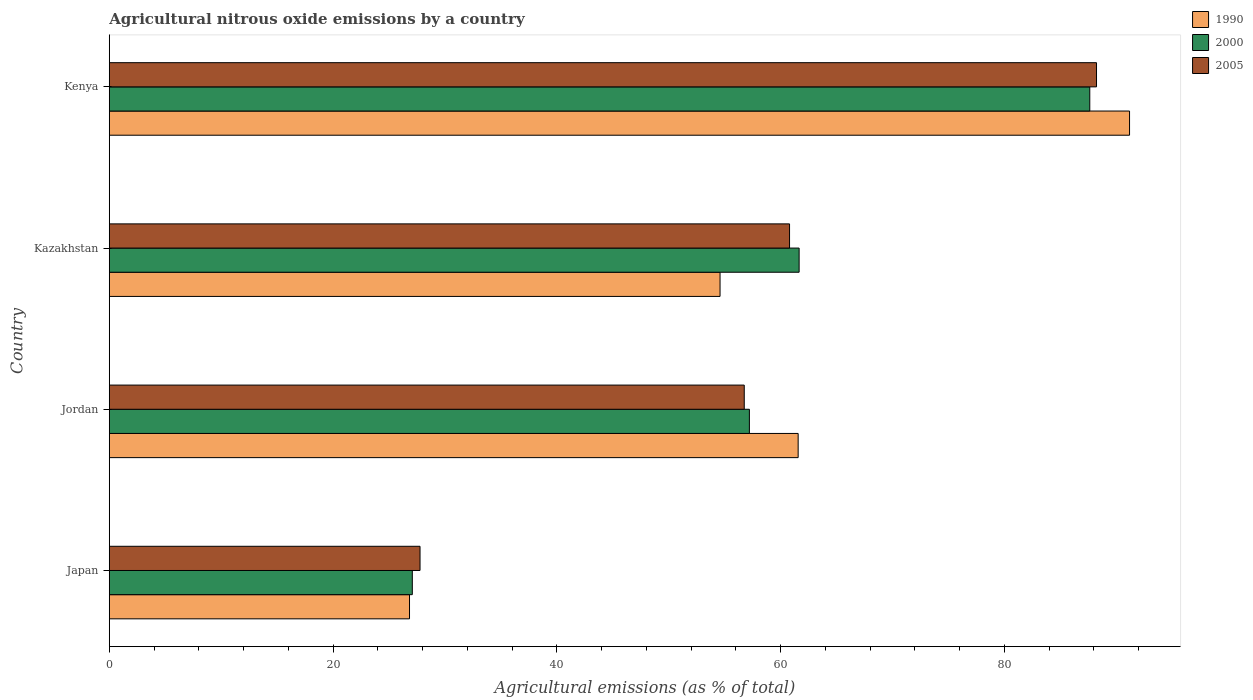How many groups of bars are there?
Ensure brevity in your answer.  4. How many bars are there on the 3rd tick from the top?
Offer a very short reply. 3. What is the label of the 2nd group of bars from the top?
Provide a succinct answer. Kazakhstan. In how many cases, is the number of bars for a given country not equal to the number of legend labels?
Provide a succinct answer. 0. What is the amount of agricultural nitrous oxide emitted in 2000 in Kenya?
Your answer should be very brief. 87.65. Across all countries, what is the maximum amount of agricultural nitrous oxide emitted in 2000?
Ensure brevity in your answer.  87.65. Across all countries, what is the minimum amount of agricultural nitrous oxide emitted in 2000?
Your answer should be compact. 27.09. In which country was the amount of agricultural nitrous oxide emitted in 2000 maximum?
Offer a terse response. Kenya. In which country was the amount of agricultural nitrous oxide emitted in 1990 minimum?
Ensure brevity in your answer.  Japan. What is the total amount of agricultural nitrous oxide emitted in 2005 in the graph?
Give a very brief answer. 233.59. What is the difference between the amount of agricultural nitrous oxide emitted in 2000 in Kazakhstan and that in Kenya?
Your response must be concise. -25.98. What is the difference between the amount of agricultural nitrous oxide emitted in 1990 in Japan and the amount of agricultural nitrous oxide emitted in 2005 in Kenya?
Ensure brevity in your answer.  -61.41. What is the average amount of agricultural nitrous oxide emitted in 2000 per country?
Make the answer very short. 58.4. What is the difference between the amount of agricultural nitrous oxide emitted in 2000 and amount of agricultural nitrous oxide emitted in 2005 in Kazakhstan?
Keep it short and to the point. 0.86. In how many countries, is the amount of agricultural nitrous oxide emitted in 2000 greater than 12 %?
Ensure brevity in your answer.  4. What is the ratio of the amount of agricultural nitrous oxide emitted in 1990 in Japan to that in Kazakhstan?
Make the answer very short. 0.49. Is the amount of agricultural nitrous oxide emitted in 1990 in Jordan less than that in Kenya?
Your answer should be compact. Yes. What is the difference between the highest and the second highest amount of agricultural nitrous oxide emitted in 1990?
Provide a succinct answer. 29.62. What is the difference between the highest and the lowest amount of agricultural nitrous oxide emitted in 1990?
Ensure brevity in your answer.  64.36. In how many countries, is the amount of agricultural nitrous oxide emitted in 2005 greater than the average amount of agricultural nitrous oxide emitted in 2005 taken over all countries?
Your response must be concise. 2. Is the sum of the amount of agricultural nitrous oxide emitted in 1990 in Japan and Kazakhstan greater than the maximum amount of agricultural nitrous oxide emitted in 2005 across all countries?
Your answer should be very brief. No. What does the 3rd bar from the top in Kazakhstan represents?
Your response must be concise. 1990. How many bars are there?
Offer a very short reply. 12. Are the values on the major ticks of X-axis written in scientific E-notation?
Offer a terse response. No. Does the graph contain any zero values?
Offer a very short reply. No. Does the graph contain grids?
Give a very brief answer. No. How many legend labels are there?
Ensure brevity in your answer.  3. What is the title of the graph?
Make the answer very short. Agricultural nitrous oxide emissions by a country. What is the label or title of the X-axis?
Ensure brevity in your answer.  Agricultural emissions (as % of total). What is the Agricultural emissions (as % of total) in 1990 in Japan?
Provide a short and direct response. 26.84. What is the Agricultural emissions (as % of total) in 2000 in Japan?
Your answer should be compact. 27.09. What is the Agricultural emissions (as % of total) of 2005 in Japan?
Provide a short and direct response. 27.78. What is the Agricultural emissions (as % of total) in 1990 in Jordan?
Offer a terse response. 61.58. What is the Agricultural emissions (as % of total) in 2000 in Jordan?
Provide a short and direct response. 57.22. What is the Agricultural emissions (as % of total) of 2005 in Jordan?
Your answer should be compact. 56.76. What is the Agricultural emissions (as % of total) in 1990 in Kazakhstan?
Provide a short and direct response. 54.6. What is the Agricultural emissions (as % of total) of 2000 in Kazakhstan?
Provide a short and direct response. 61.66. What is the Agricultural emissions (as % of total) in 2005 in Kazakhstan?
Give a very brief answer. 60.81. What is the Agricultural emissions (as % of total) of 1990 in Kenya?
Offer a very short reply. 91.2. What is the Agricultural emissions (as % of total) in 2000 in Kenya?
Your response must be concise. 87.65. What is the Agricultural emissions (as % of total) in 2005 in Kenya?
Make the answer very short. 88.25. Across all countries, what is the maximum Agricultural emissions (as % of total) in 1990?
Your answer should be compact. 91.2. Across all countries, what is the maximum Agricultural emissions (as % of total) of 2000?
Provide a short and direct response. 87.65. Across all countries, what is the maximum Agricultural emissions (as % of total) of 2005?
Keep it short and to the point. 88.25. Across all countries, what is the minimum Agricultural emissions (as % of total) in 1990?
Ensure brevity in your answer.  26.84. Across all countries, what is the minimum Agricultural emissions (as % of total) of 2000?
Provide a succinct answer. 27.09. Across all countries, what is the minimum Agricultural emissions (as % of total) of 2005?
Make the answer very short. 27.78. What is the total Agricultural emissions (as % of total) of 1990 in the graph?
Ensure brevity in your answer.  234.21. What is the total Agricultural emissions (as % of total) in 2000 in the graph?
Make the answer very short. 233.62. What is the total Agricultural emissions (as % of total) of 2005 in the graph?
Offer a very short reply. 233.59. What is the difference between the Agricultural emissions (as % of total) of 1990 in Japan and that in Jordan?
Your answer should be compact. -34.74. What is the difference between the Agricultural emissions (as % of total) of 2000 in Japan and that in Jordan?
Make the answer very short. -30.13. What is the difference between the Agricultural emissions (as % of total) in 2005 in Japan and that in Jordan?
Provide a short and direct response. -28.98. What is the difference between the Agricultural emissions (as % of total) in 1990 in Japan and that in Kazakhstan?
Provide a succinct answer. -27.76. What is the difference between the Agricultural emissions (as % of total) in 2000 in Japan and that in Kazakhstan?
Your answer should be compact. -34.58. What is the difference between the Agricultural emissions (as % of total) in 2005 in Japan and that in Kazakhstan?
Provide a succinct answer. -33.03. What is the difference between the Agricultural emissions (as % of total) of 1990 in Japan and that in Kenya?
Offer a terse response. -64.36. What is the difference between the Agricultural emissions (as % of total) of 2000 in Japan and that in Kenya?
Keep it short and to the point. -60.56. What is the difference between the Agricultural emissions (as % of total) in 2005 in Japan and that in Kenya?
Provide a short and direct response. -60.47. What is the difference between the Agricultural emissions (as % of total) in 1990 in Jordan and that in Kazakhstan?
Provide a succinct answer. 6.98. What is the difference between the Agricultural emissions (as % of total) of 2000 in Jordan and that in Kazakhstan?
Offer a very short reply. -4.45. What is the difference between the Agricultural emissions (as % of total) of 2005 in Jordan and that in Kazakhstan?
Give a very brief answer. -4.05. What is the difference between the Agricultural emissions (as % of total) of 1990 in Jordan and that in Kenya?
Your answer should be compact. -29.62. What is the difference between the Agricultural emissions (as % of total) in 2000 in Jordan and that in Kenya?
Make the answer very short. -30.43. What is the difference between the Agricultural emissions (as % of total) in 2005 in Jordan and that in Kenya?
Offer a very short reply. -31.49. What is the difference between the Agricultural emissions (as % of total) of 1990 in Kazakhstan and that in Kenya?
Give a very brief answer. -36.6. What is the difference between the Agricultural emissions (as % of total) of 2000 in Kazakhstan and that in Kenya?
Ensure brevity in your answer.  -25.98. What is the difference between the Agricultural emissions (as % of total) of 2005 in Kazakhstan and that in Kenya?
Make the answer very short. -27.44. What is the difference between the Agricultural emissions (as % of total) of 1990 in Japan and the Agricultural emissions (as % of total) of 2000 in Jordan?
Offer a very short reply. -30.38. What is the difference between the Agricultural emissions (as % of total) in 1990 in Japan and the Agricultural emissions (as % of total) in 2005 in Jordan?
Your answer should be very brief. -29.92. What is the difference between the Agricultural emissions (as % of total) in 2000 in Japan and the Agricultural emissions (as % of total) in 2005 in Jordan?
Offer a very short reply. -29.67. What is the difference between the Agricultural emissions (as % of total) of 1990 in Japan and the Agricultural emissions (as % of total) of 2000 in Kazakhstan?
Your response must be concise. -34.83. What is the difference between the Agricultural emissions (as % of total) of 1990 in Japan and the Agricultural emissions (as % of total) of 2005 in Kazakhstan?
Your response must be concise. -33.97. What is the difference between the Agricultural emissions (as % of total) in 2000 in Japan and the Agricultural emissions (as % of total) in 2005 in Kazakhstan?
Your answer should be very brief. -33.72. What is the difference between the Agricultural emissions (as % of total) of 1990 in Japan and the Agricultural emissions (as % of total) of 2000 in Kenya?
Give a very brief answer. -60.81. What is the difference between the Agricultural emissions (as % of total) of 1990 in Japan and the Agricultural emissions (as % of total) of 2005 in Kenya?
Provide a short and direct response. -61.41. What is the difference between the Agricultural emissions (as % of total) in 2000 in Japan and the Agricultural emissions (as % of total) in 2005 in Kenya?
Give a very brief answer. -61.16. What is the difference between the Agricultural emissions (as % of total) of 1990 in Jordan and the Agricultural emissions (as % of total) of 2000 in Kazakhstan?
Provide a succinct answer. -0.09. What is the difference between the Agricultural emissions (as % of total) in 1990 in Jordan and the Agricultural emissions (as % of total) in 2005 in Kazakhstan?
Keep it short and to the point. 0.77. What is the difference between the Agricultural emissions (as % of total) in 2000 in Jordan and the Agricultural emissions (as % of total) in 2005 in Kazakhstan?
Give a very brief answer. -3.59. What is the difference between the Agricultural emissions (as % of total) of 1990 in Jordan and the Agricultural emissions (as % of total) of 2000 in Kenya?
Make the answer very short. -26.07. What is the difference between the Agricultural emissions (as % of total) of 1990 in Jordan and the Agricultural emissions (as % of total) of 2005 in Kenya?
Give a very brief answer. -26.67. What is the difference between the Agricultural emissions (as % of total) of 2000 in Jordan and the Agricultural emissions (as % of total) of 2005 in Kenya?
Make the answer very short. -31.03. What is the difference between the Agricultural emissions (as % of total) of 1990 in Kazakhstan and the Agricultural emissions (as % of total) of 2000 in Kenya?
Your answer should be compact. -33.05. What is the difference between the Agricultural emissions (as % of total) of 1990 in Kazakhstan and the Agricultural emissions (as % of total) of 2005 in Kenya?
Your answer should be very brief. -33.65. What is the difference between the Agricultural emissions (as % of total) of 2000 in Kazakhstan and the Agricultural emissions (as % of total) of 2005 in Kenya?
Give a very brief answer. -26.58. What is the average Agricultural emissions (as % of total) in 1990 per country?
Make the answer very short. 58.55. What is the average Agricultural emissions (as % of total) of 2000 per country?
Offer a terse response. 58.4. What is the average Agricultural emissions (as % of total) of 2005 per country?
Keep it short and to the point. 58.4. What is the difference between the Agricultural emissions (as % of total) in 1990 and Agricultural emissions (as % of total) in 2000 in Japan?
Give a very brief answer. -0.25. What is the difference between the Agricultural emissions (as % of total) of 1990 and Agricultural emissions (as % of total) of 2005 in Japan?
Keep it short and to the point. -0.94. What is the difference between the Agricultural emissions (as % of total) in 2000 and Agricultural emissions (as % of total) in 2005 in Japan?
Your answer should be compact. -0.69. What is the difference between the Agricultural emissions (as % of total) of 1990 and Agricultural emissions (as % of total) of 2000 in Jordan?
Your answer should be compact. 4.36. What is the difference between the Agricultural emissions (as % of total) of 1990 and Agricultural emissions (as % of total) of 2005 in Jordan?
Provide a succinct answer. 4.82. What is the difference between the Agricultural emissions (as % of total) in 2000 and Agricultural emissions (as % of total) in 2005 in Jordan?
Ensure brevity in your answer.  0.46. What is the difference between the Agricultural emissions (as % of total) in 1990 and Agricultural emissions (as % of total) in 2000 in Kazakhstan?
Your response must be concise. -7.07. What is the difference between the Agricultural emissions (as % of total) in 1990 and Agricultural emissions (as % of total) in 2005 in Kazakhstan?
Provide a short and direct response. -6.21. What is the difference between the Agricultural emissions (as % of total) of 2000 and Agricultural emissions (as % of total) of 2005 in Kazakhstan?
Offer a very short reply. 0.86. What is the difference between the Agricultural emissions (as % of total) of 1990 and Agricultural emissions (as % of total) of 2000 in Kenya?
Ensure brevity in your answer.  3.55. What is the difference between the Agricultural emissions (as % of total) of 1990 and Agricultural emissions (as % of total) of 2005 in Kenya?
Offer a terse response. 2.95. What is the difference between the Agricultural emissions (as % of total) of 2000 and Agricultural emissions (as % of total) of 2005 in Kenya?
Keep it short and to the point. -0.6. What is the ratio of the Agricultural emissions (as % of total) of 1990 in Japan to that in Jordan?
Make the answer very short. 0.44. What is the ratio of the Agricultural emissions (as % of total) in 2000 in Japan to that in Jordan?
Your answer should be very brief. 0.47. What is the ratio of the Agricultural emissions (as % of total) in 2005 in Japan to that in Jordan?
Keep it short and to the point. 0.49. What is the ratio of the Agricultural emissions (as % of total) of 1990 in Japan to that in Kazakhstan?
Provide a short and direct response. 0.49. What is the ratio of the Agricultural emissions (as % of total) in 2000 in Japan to that in Kazakhstan?
Provide a succinct answer. 0.44. What is the ratio of the Agricultural emissions (as % of total) of 2005 in Japan to that in Kazakhstan?
Ensure brevity in your answer.  0.46. What is the ratio of the Agricultural emissions (as % of total) of 1990 in Japan to that in Kenya?
Your response must be concise. 0.29. What is the ratio of the Agricultural emissions (as % of total) in 2000 in Japan to that in Kenya?
Provide a succinct answer. 0.31. What is the ratio of the Agricultural emissions (as % of total) of 2005 in Japan to that in Kenya?
Ensure brevity in your answer.  0.31. What is the ratio of the Agricultural emissions (as % of total) of 1990 in Jordan to that in Kazakhstan?
Make the answer very short. 1.13. What is the ratio of the Agricultural emissions (as % of total) of 2000 in Jordan to that in Kazakhstan?
Your answer should be compact. 0.93. What is the ratio of the Agricultural emissions (as % of total) in 2005 in Jordan to that in Kazakhstan?
Provide a short and direct response. 0.93. What is the ratio of the Agricultural emissions (as % of total) of 1990 in Jordan to that in Kenya?
Provide a succinct answer. 0.68. What is the ratio of the Agricultural emissions (as % of total) in 2000 in Jordan to that in Kenya?
Provide a short and direct response. 0.65. What is the ratio of the Agricultural emissions (as % of total) in 2005 in Jordan to that in Kenya?
Offer a terse response. 0.64. What is the ratio of the Agricultural emissions (as % of total) of 1990 in Kazakhstan to that in Kenya?
Offer a very short reply. 0.6. What is the ratio of the Agricultural emissions (as % of total) in 2000 in Kazakhstan to that in Kenya?
Give a very brief answer. 0.7. What is the ratio of the Agricultural emissions (as % of total) of 2005 in Kazakhstan to that in Kenya?
Offer a terse response. 0.69. What is the difference between the highest and the second highest Agricultural emissions (as % of total) in 1990?
Your answer should be very brief. 29.62. What is the difference between the highest and the second highest Agricultural emissions (as % of total) in 2000?
Your answer should be compact. 25.98. What is the difference between the highest and the second highest Agricultural emissions (as % of total) in 2005?
Your answer should be very brief. 27.44. What is the difference between the highest and the lowest Agricultural emissions (as % of total) of 1990?
Your response must be concise. 64.36. What is the difference between the highest and the lowest Agricultural emissions (as % of total) of 2000?
Give a very brief answer. 60.56. What is the difference between the highest and the lowest Agricultural emissions (as % of total) in 2005?
Provide a short and direct response. 60.47. 